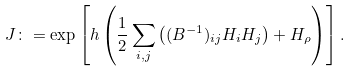Convert formula to latex. <formula><loc_0><loc_0><loc_500><loc_500>J \colon = \exp \left [ h \left ( \frac { 1 } { 2 } \sum _ { i , j } \left ( ( B ^ { - 1 } ) _ { i j } H _ { i } H _ { j } \right ) + H _ { \rho } \right ) \right ] .</formula> 